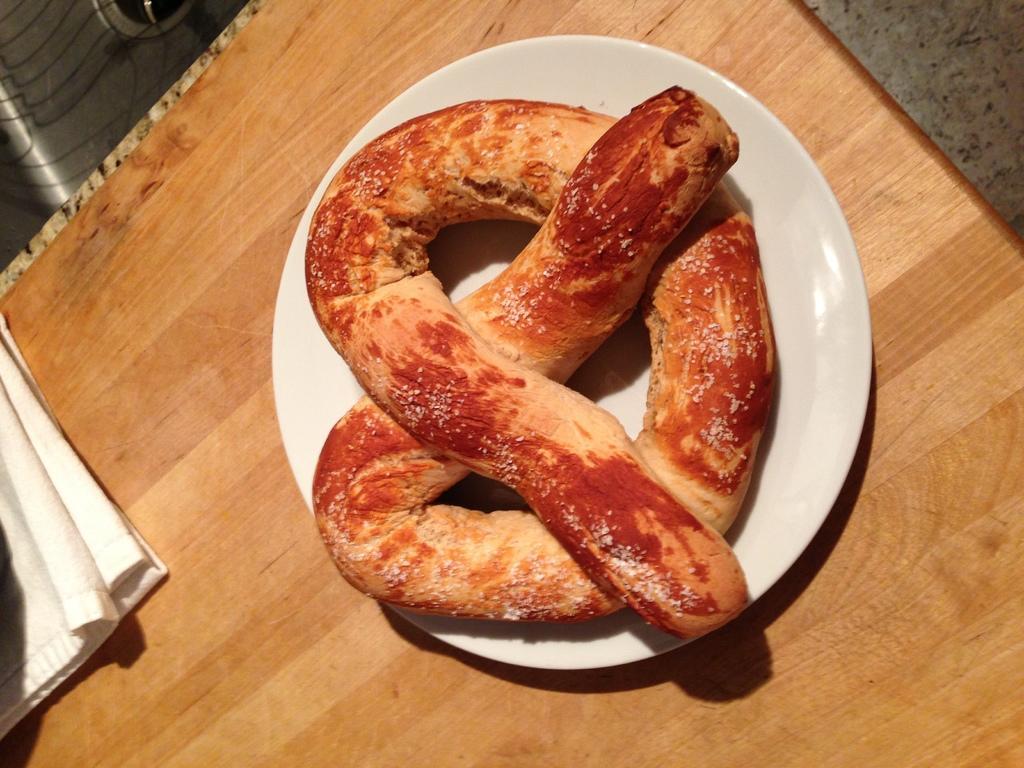Describe this image in one or two sentences. In this image I can see a food item in a plate, napkin on the table. This image is taken may be in a room. 